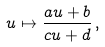Convert formula to latex. <formula><loc_0><loc_0><loc_500><loc_500>u \mapsto \frac { a u + b } { c u + d } \, ,</formula> 